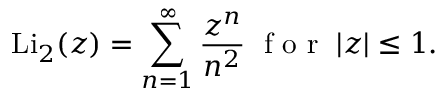Convert formula to latex. <formula><loc_0><loc_0><loc_500><loc_500>L i _ { 2 } ( z ) = \sum _ { n = 1 } ^ { \infty } \frac { z ^ { n } } { n ^ { 2 } } \, f o r \, | z | \leq 1 .</formula> 